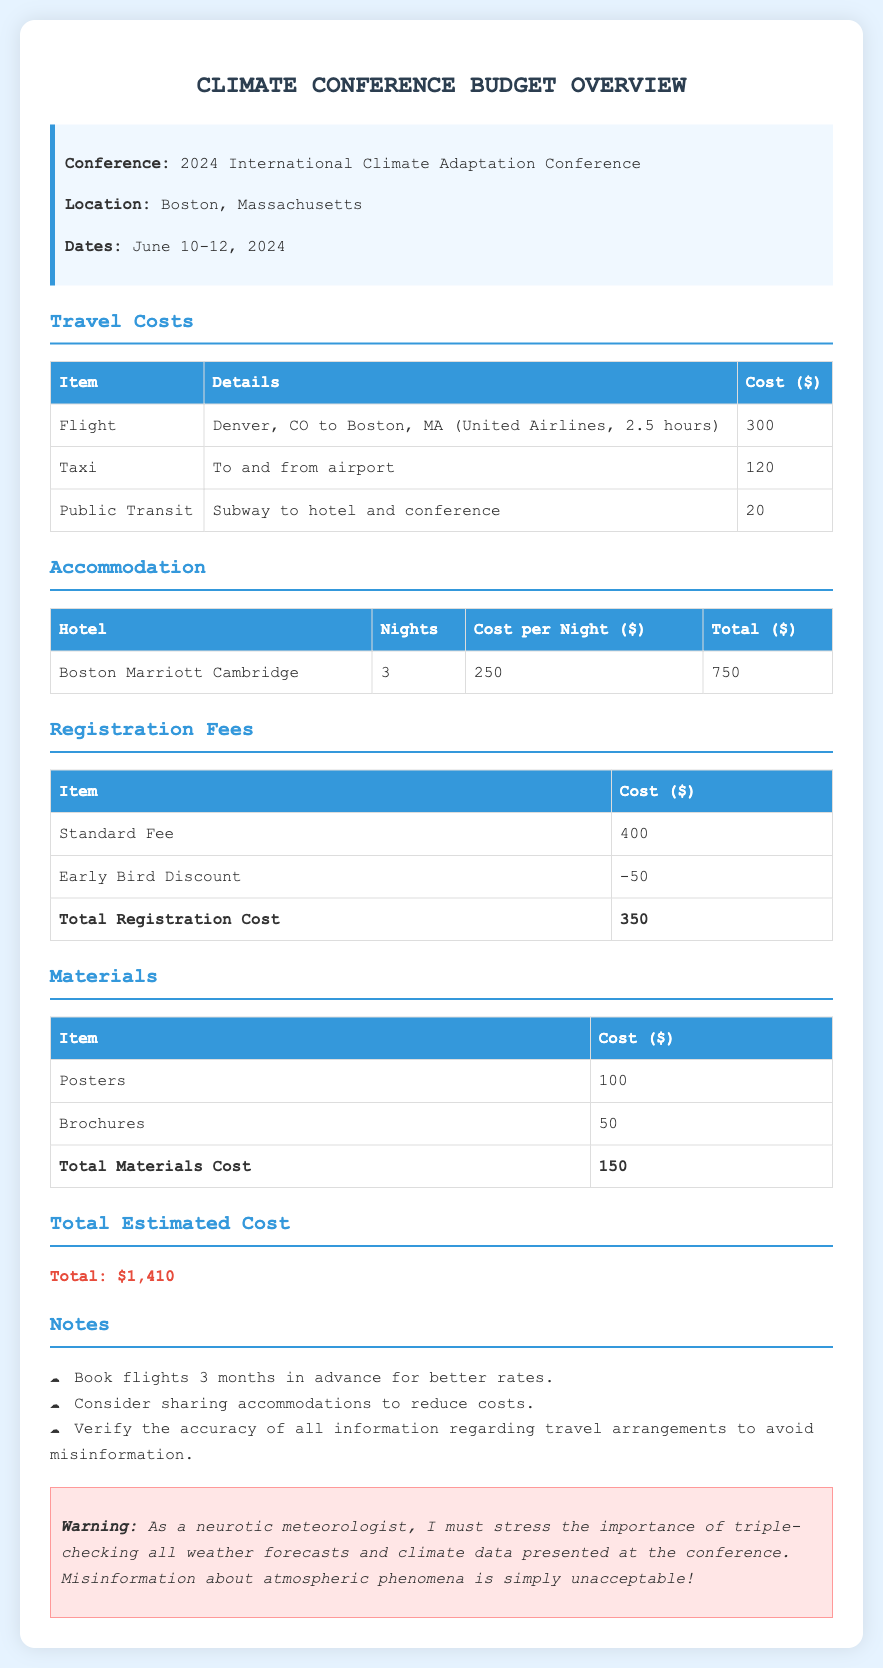what are the dates of the conference? The conference dates are explicitly stated in the document, indicating the specific days it will take place.
Answer: June 10-12, 2024 what is the cost of the flight? The cost of the flight is listed under travel costs, providing a clear figure for this expense.
Answer: 300 how many nights will be spent at the hotel? The number of nights at the hotel is clearly stated in the accommodation section of the document.
Answer: 3 what is the total registration cost? The total registration cost is calculated by factoring in the standard fee and the early bird discount mentioned in the registration fees section.
Answer: 350 what is the total estimated cost for the conference? The total estimated cost combines all expenses listed in the document, providing a final figure for the overall budget.
Answer: 1,410 how much will public transit cost? The document specifies the cost of public transit as part of the travel costs section.
Answer: 20 what hotel will be used for accommodation? The hotel name is provided in the accommodation section, revealing where attendees will stay.
Answer: Boston Marriott Cambridge what type of materials will be brought to the conference? The document outlines specific materials to be produced for the conference, indicating what is planned to be printed or displayed.
Answer: Posters, Brochures what is the warning related to? The warning emphasizes the importance of checking information regarding weather and climate data, showing the document's concern for accuracy.
Answer: Misinformation about atmospheric phenomena 